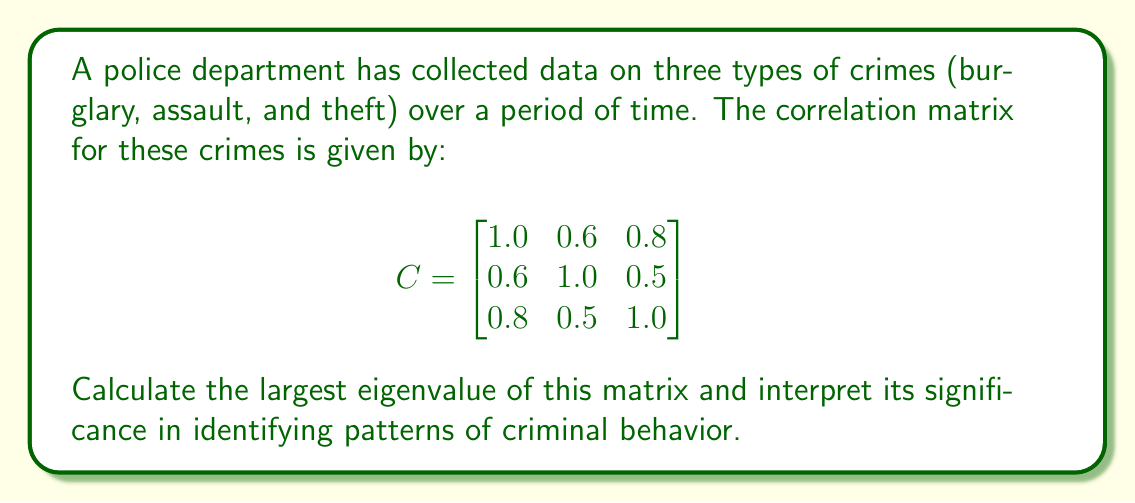Show me your answer to this math problem. To find the eigenvalues, we need to solve the characteristic equation:

$$\det(C - \lambda I) = 0$$

1) First, let's set up the matrix $C - \lambda I$:

   $$C - \lambda I = \begin{bmatrix}
   1-\lambda & 0.6 & 0.8 \\
   0.6 & 1-\lambda & 0.5 \\
   0.8 & 0.5 & 1-\lambda
   \end{bmatrix}$$

2) Now, we calculate the determinant:

   $$(1-\lambda)[(1-\lambda)(1-\lambda) - 0.25] - 0.6[0.6(1-\lambda) - 0.4] + 0.8[0.3 - 0.5(1-\lambda)]$$

3) Simplifying:

   $$(1-\lambda)[(1-\lambda)^2 - 0.25] - 0.6[0.6-0.6\lambda - 0.4] + 0.8[0.3 - 0.5+0.5\lambda]$$
   
   $$(1-\lambda)[(1-\lambda)^2 - 0.25] - 0.6[0.2-0.6\lambda] + 0.8[-0.2+0.5\lambda]$$
   
   $$(1-\lambda)^3 - 0.25(1-\lambda) - 0.12 + 0.36\lambda - 0.16 + 0.4\lambda$$

4) Expanding:

   $$1 - 3\lambda + 3\lambda^2 - \lambda^3 - 0.25 + 0.25\lambda - 0.12 - 0.16 + 0.76\lambda$$
   
   $$-\lambda^3 + 3\lambda^2 + (0.25 + 0.76 - 3)\lambda + (1 - 0.25 - 0.12 - 0.16)$$
   
   $$-\lambda^3 + 3\lambda^2 - 1.99\lambda + 0.47 = 0$$

5) The largest root of this equation is the largest eigenvalue. Using numerical methods, we find the largest root is approximately 2.2815.

The largest eigenvalue represents the direction of maximum variance in the data. In this context, it indicates the strongest pattern of correlation among the three types of crimes. A high value (2.2815 out of a maximum possible 3) suggests a strong overall correlation between these crimes, implying that they often occur together or follow similar patterns.
Answer: 2.2815 